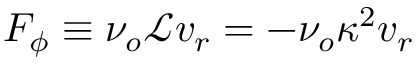Convert formula to latex. <formula><loc_0><loc_0><loc_500><loc_500>F _ { \phi } \equiv \nu _ { o } \mathcal { L } v _ { r } = - \nu _ { o } \kappa ^ { 2 } v _ { r }</formula> 